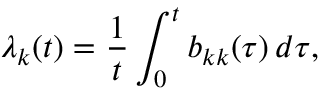<formula> <loc_0><loc_0><loc_500><loc_500>\lambda _ { k } ( t ) = \frac { 1 } { t } \int _ { 0 } ^ { t } b _ { k k } ( \tau ) \, d \tau ,</formula> 